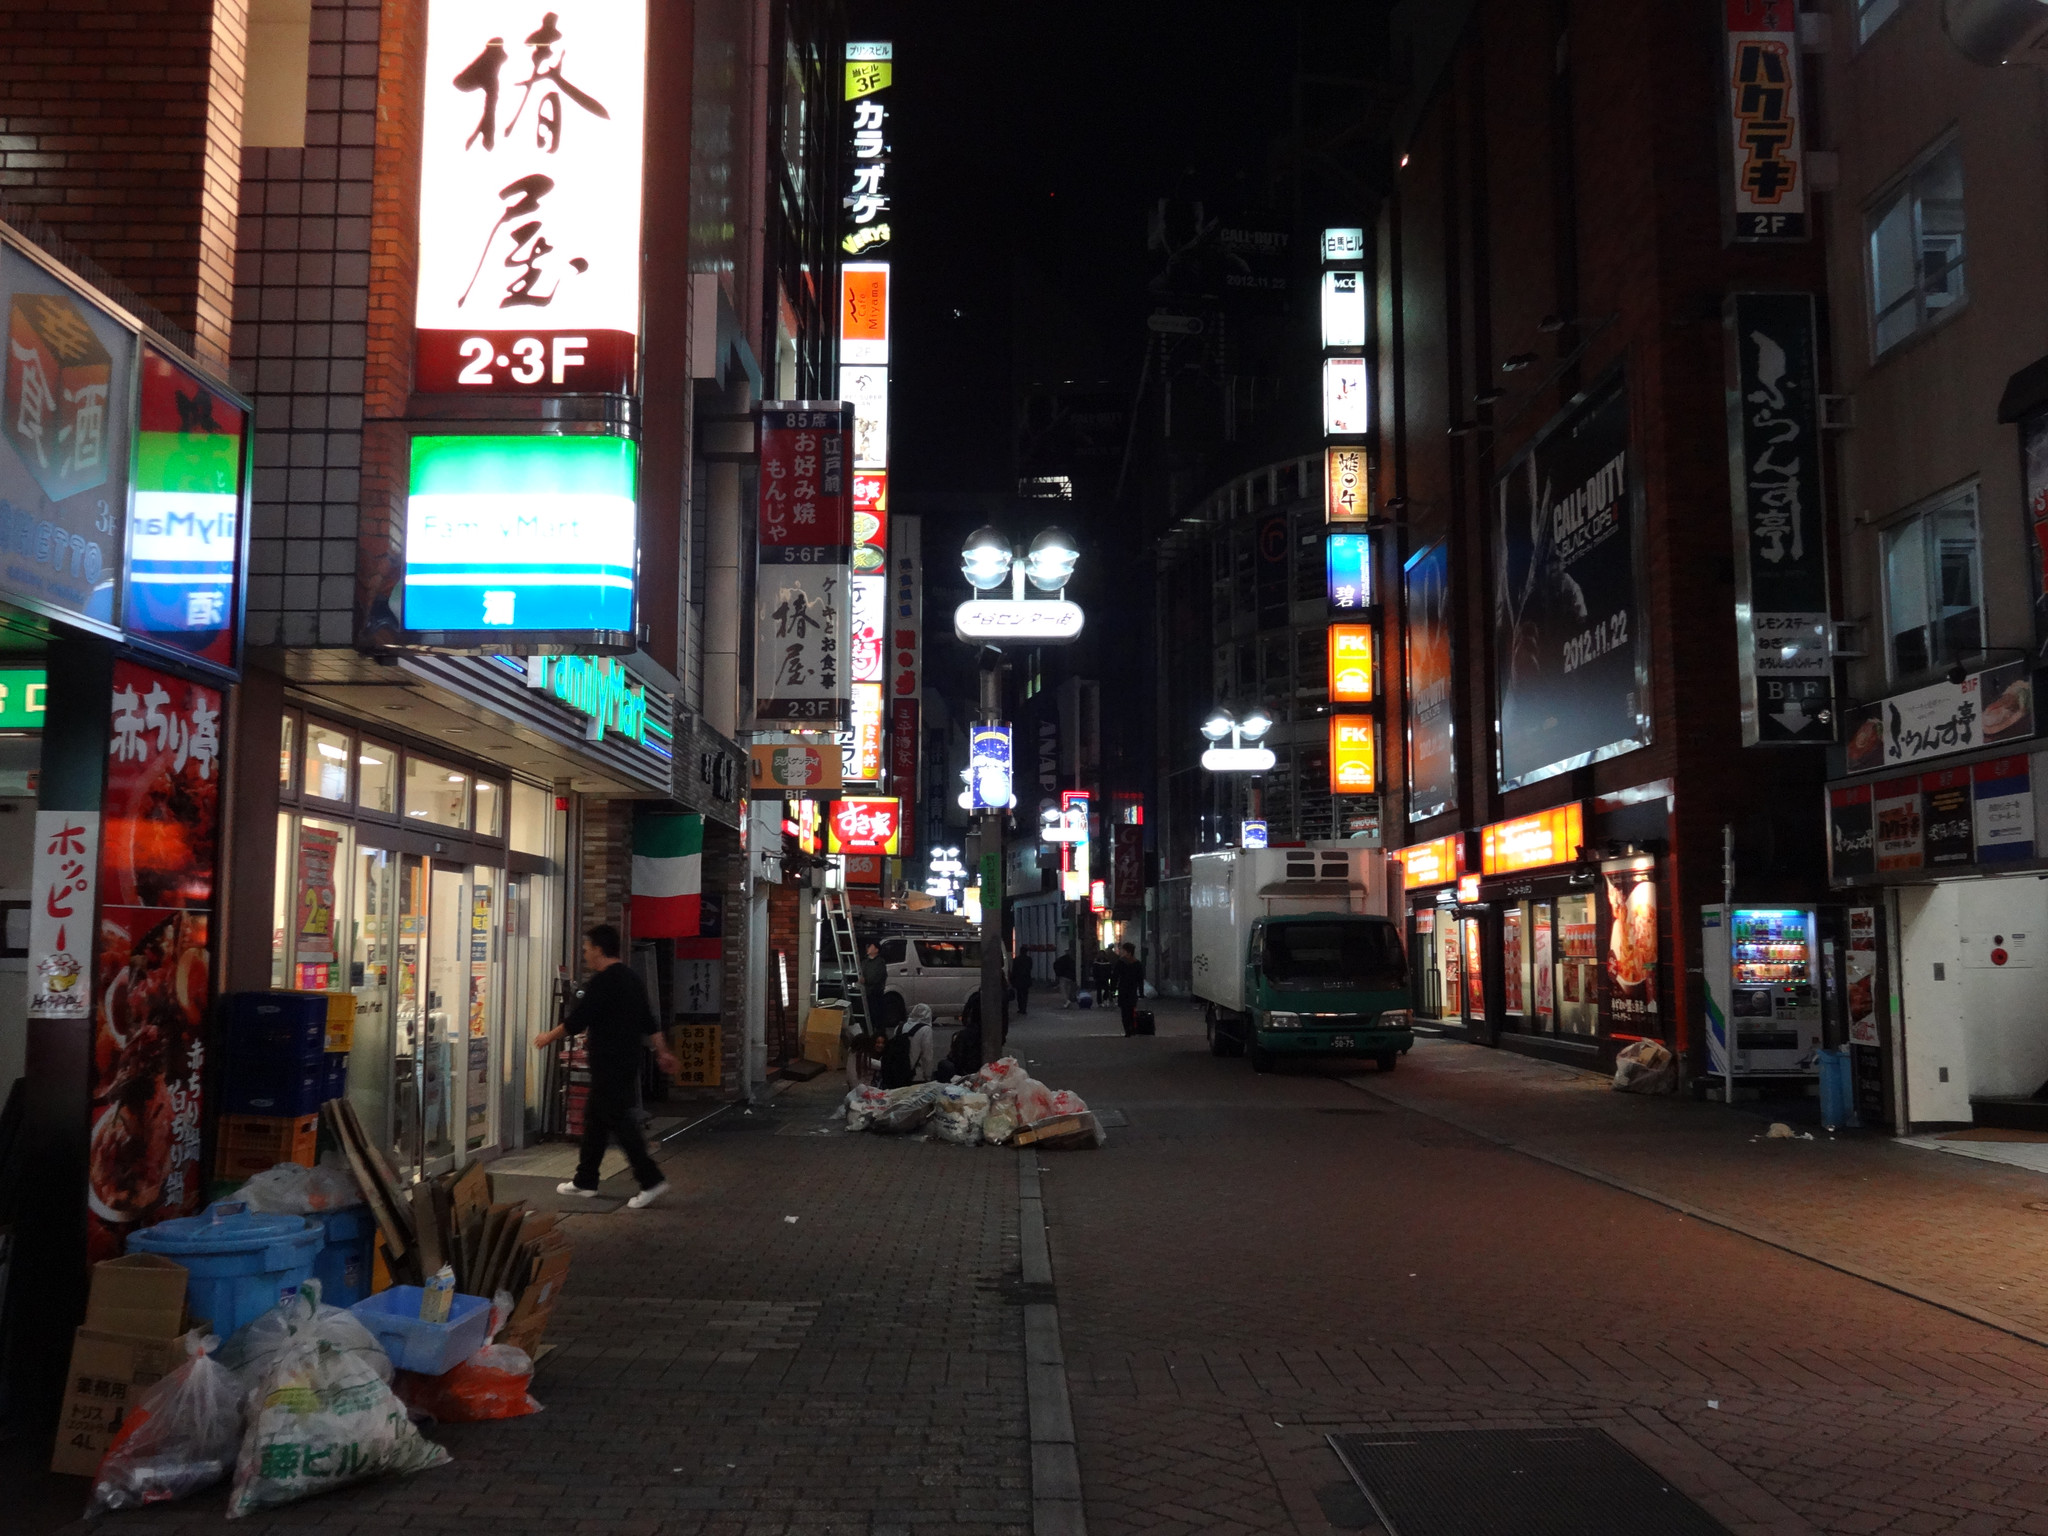Describe this image in one or two sentences. This image consists of buildings and boards along with the lights. At the bottom, there is a road. In the front, we can see a van moving on the road. On the left, there are many things kept on the pavement. At the top, there is sky. 